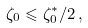<formula> <loc_0><loc_0><loc_500><loc_500>\zeta _ { 0 } \leqslant \zeta _ { 0 } ^ { * } / 2 \, ,</formula> 